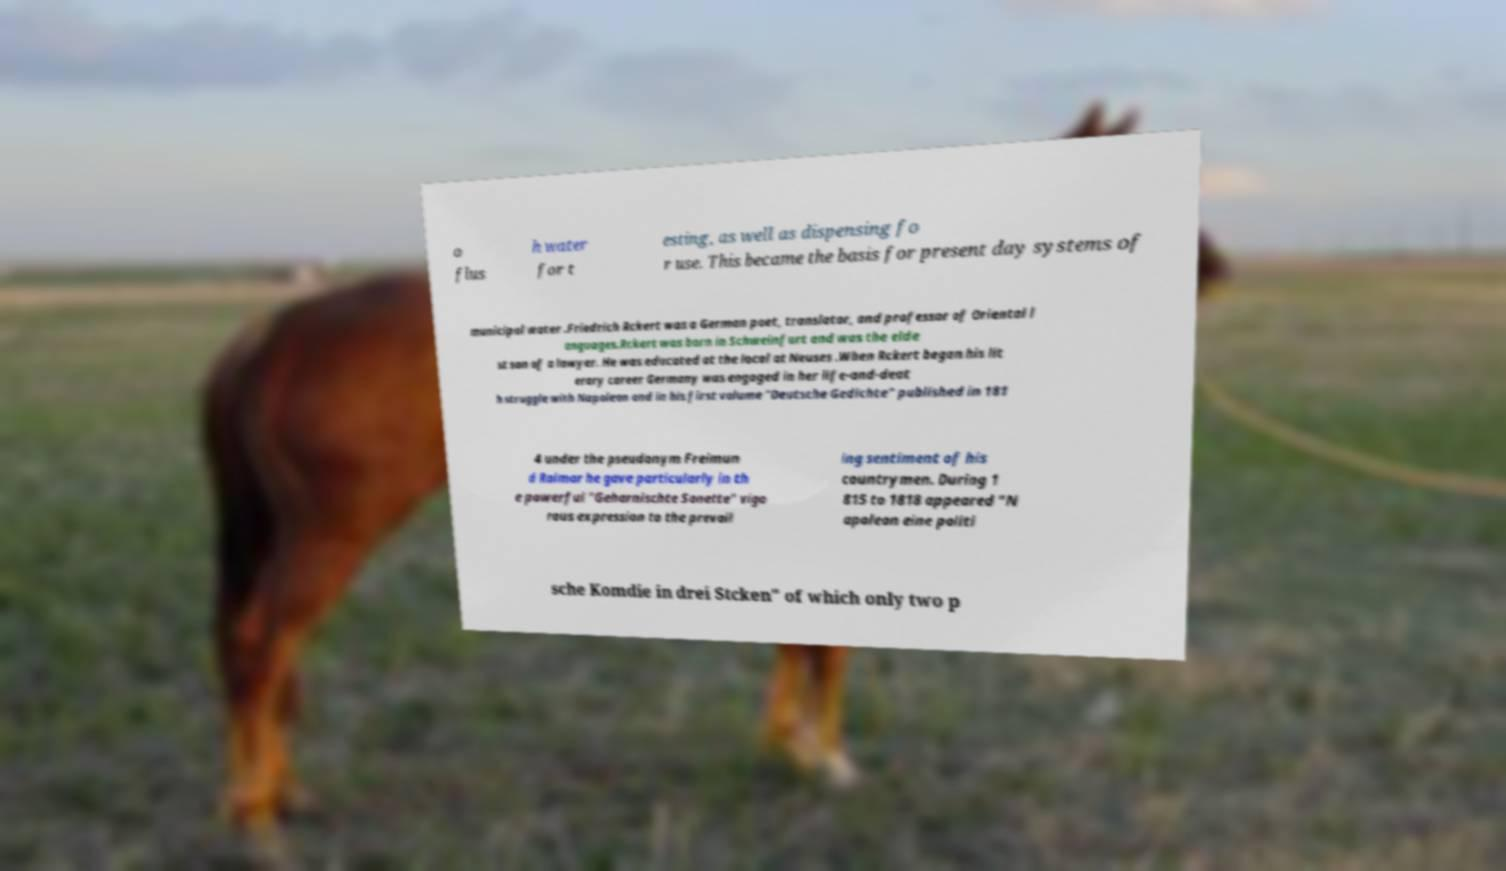Could you assist in decoding the text presented in this image and type it out clearly? o flus h water for t esting, as well as dispensing fo r use. This became the basis for present day systems of municipal water .Friedrich Rckert was a German poet, translator, and professor of Oriental l anguages.Rckert was born in Schweinfurt and was the elde st son of a lawyer. He was educated at the local at Neuses .When Rckert began his lit erary career Germany was engaged in her life-and-deat h struggle with Napoleon and in his first volume "Deutsche Gedichte" published in 181 4 under the pseudonym Freimun d Raimar he gave particularly in th e powerful "Geharnischte Sonette" vigo rous expression to the prevail ing sentiment of his countrymen. During 1 815 to 1818 appeared "N apoleon eine politi sche Komdie in drei Stcken" of which only two p 